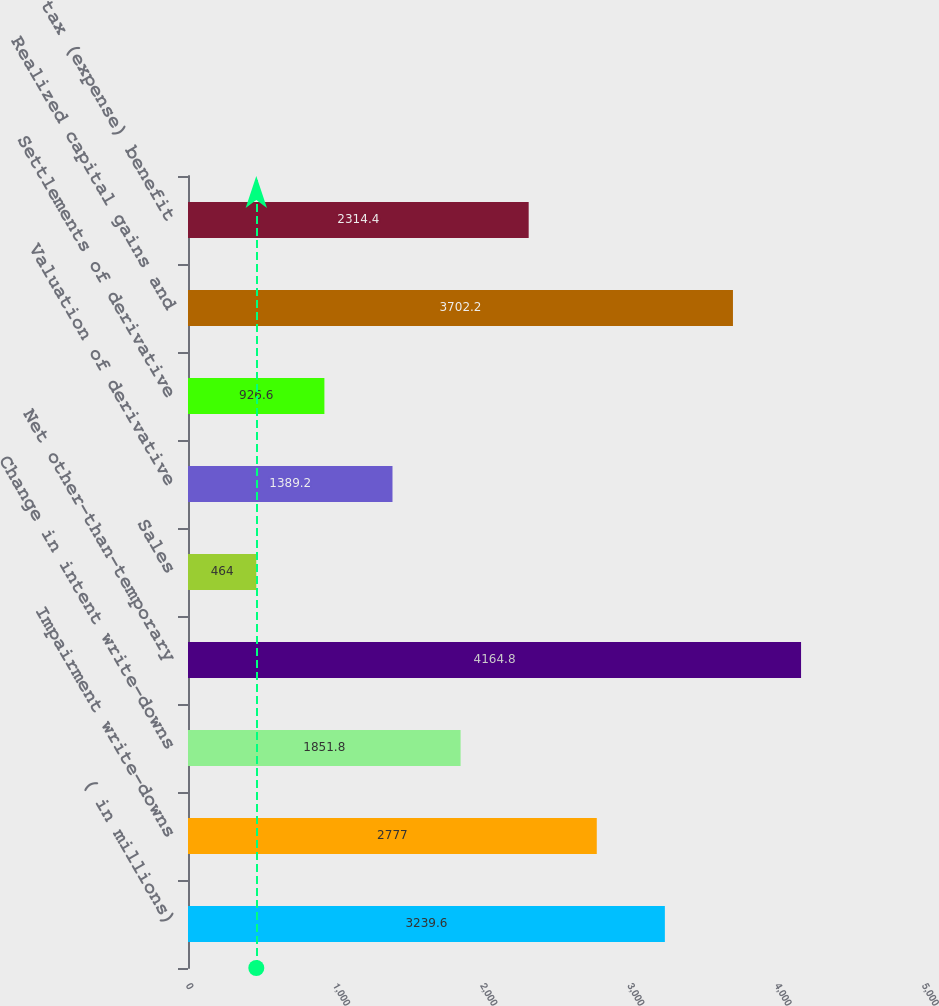Convert chart to OTSL. <chart><loc_0><loc_0><loc_500><loc_500><bar_chart><fcel>( in millions)<fcel>Impairment write-downs<fcel>Change in intent write-downs<fcel>Net other-than-temporary<fcel>Sales<fcel>Valuation of derivative<fcel>Settlements of derivative<fcel>Realized capital gains and<fcel>Income tax (expense) benefit<nl><fcel>3239.6<fcel>2777<fcel>1851.8<fcel>4164.8<fcel>464<fcel>1389.2<fcel>926.6<fcel>3702.2<fcel>2314.4<nl></chart> 